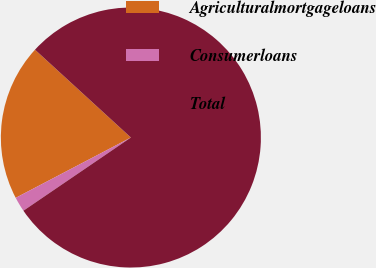Convert chart to OTSL. <chart><loc_0><loc_0><loc_500><loc_500><pie_chart><fcel>Agriculturalmortgageloans<fcel>Consumerloans<fcel>Total<nl><fcel>19.48%<fcel>1.84%<fcel>78.68%<nl></chart> 